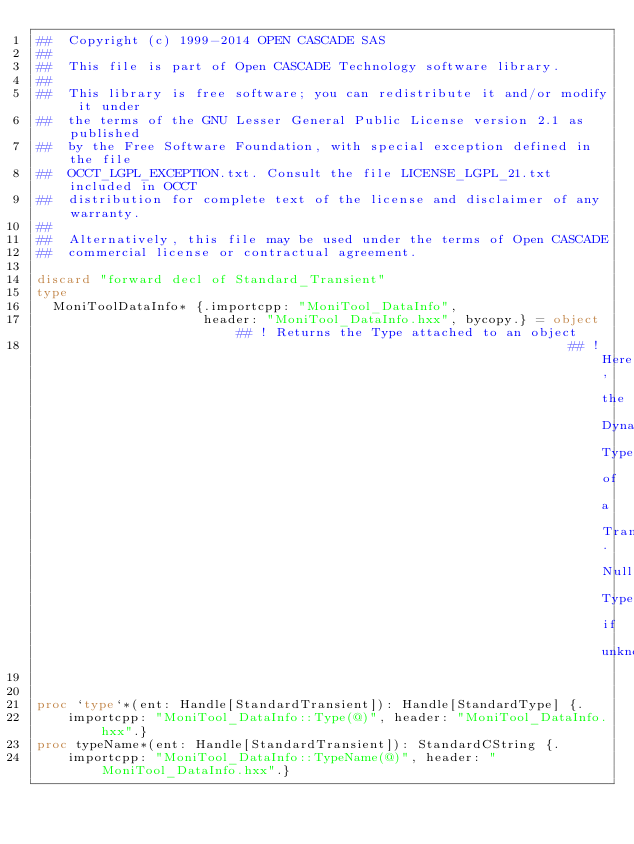<code> <loc_0><loc_0><loc_500><loc_500><_Nim_>##  Copyright (c) 1999-2014 OPEN CASCADE SAS
##
##  This file is part of Open CASCADE Technology software library.
##
##  This library is free software; you can redistribute it and/or modify it under
##  the terms of the GNU Lesser General Public License version 2.1 as published
##  by the Free Software Foundation, with special exception defined in the file
##  OCCT_LGPL_EXCEPTION.txt. Consult the file LICENSE_LGPL_21.txt included in OCCT
##  distribution for complete text of the license and disclaimer of any warranty.
##
##  Alternatively, this file may be used under the terms of Open CASCADE
##  commercial license or contractual agreement.

discard "forward decl of Standard_Transient"
type
  MoniToolDataInfo* {.importcpp: "MoniTool_DataInfo",
                     header: "MoniTool_DataInfo.hxx", bycopy.} = object ## ! Returns the Type attached to an object
                                                                   ## ! Here, the Dynamic Type of a Transient. Null Type if unknown


proc `type`*(ent: Handle[StandardTransient]): Handle[StandardType] {.
    importcpp: "MoniTool_DataInfo::Type(@)", header: "MoniTool_DataInfo.hxx".}
proc typeName*(ent: Handle[StandardTransient]): StandardCString {.
    importcpp: "MoniTool_DataInfo::TypeName(@)", header: "MoniTool_DataInfo.hxx".}

























</code> 